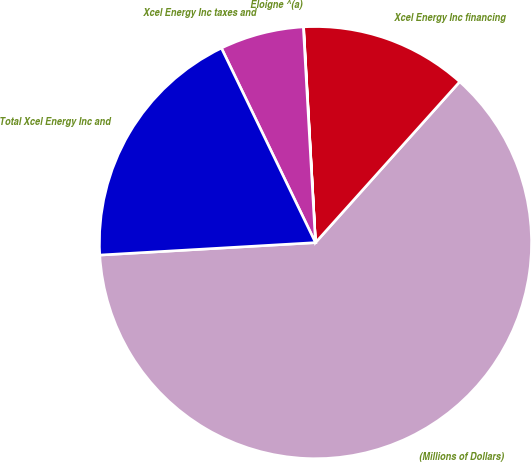<chart> <loc_0><loc_0><loc_500><loc_500><pie_chart><fcel>(Millions of Dollars)<fcel>Xcel Energy Inc financing<fcel>Eloigne ^(a)<fcel>Xcel Energy Inc taxes and<fcel>Total Xcel Energy Inc and<nl><fcel>62.45%<fcel>12.51%<fcel>0.02%<fcel>6.27%<fcel>18.75%<nl></chart> 